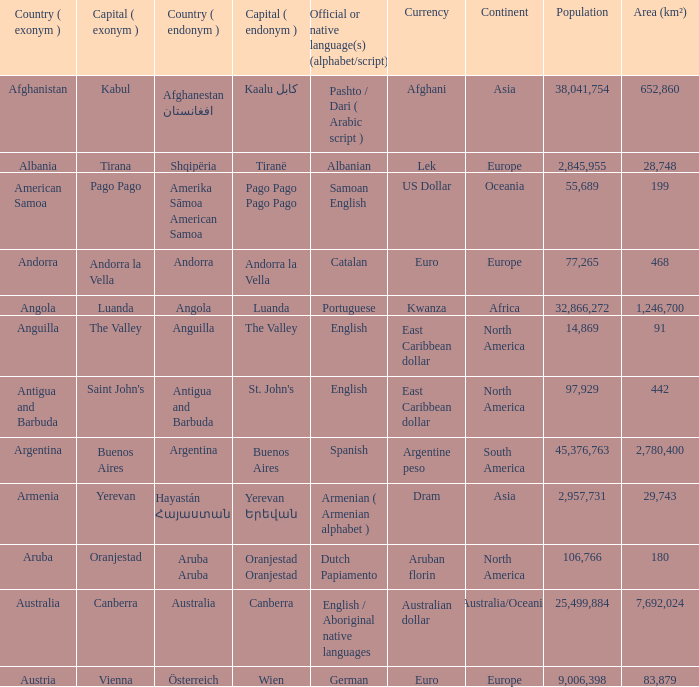Parse the table in full. {'header': ['Country ( exonym )', 'Capital ( exonym )', 'Country ( endonym )', 'Capital ( endonym )', 'Official or native language(s) (alphabet/script)', 'Currency', 'Continent', 'Population', 'Area (km²)'], 'rows': [['Afghanistan', 'Kabul', 'Afghanestan افغانستان', 'Kaalu كابل', 'Pashto / Dari ( Arabic script )', 'Afghani', 'Asia', '38,041,754', '652,860'], ['Albania', 'Tirana', 'Shqipëria', 'Tiranë', 'Albanian', 'Lek', 'Europe', '2,845,955', '28,748'], ['American Samoa', 'Pago Pago', 'Amerika Sāmoa American Samoa', 'Pago Pago Pago Pago', 'Samoan English', 'US Dollar', 'Oceania', '55,689', '199'], ['Andorra', 'Andorra la Vella', 'Andorra', 'Andorra la Vella', 'Catalan', 'Euro', 'Europe', '77,265', '468'], ['Angola', 'Luanda', 'Angola', 'Luanda', 'Portuguese', 'Kwanza', 'Africa', '32,866,272', '1,246,700'], ['Anguilla', 'The Valley', 'Anguilla', 'The Valley', 'English', 'East Caribbean dollar', 'North America', '14,869', '91'], ['Antigua and Barbuda', "Saint John's", 'Antigua and Barbuda', "St. John's", 'English', 'East Caribbean dollar', 'North America', '97,929', '442'], ['Argentina', 'Buenos Aires', 'Argentina', 'Buenos Aires', 'Spanish', 'Argentine peso', 'South America', '45,376,763', '2,780,400'], ['Armenia', 'Yerevan', 'Hayastán Հայաստան', 'Yerevan Երեվան', 'Armenian ( Armenian alphabet )', 'Dram', 'Asia', '2,957,731', '29,743'], ['Aruba', 'Oranjestad', 'Aruba Aruba', 'Oranjestad Oranjestad', 'Dutch Papiamento', 'Aruban florin', 'North America', '106,766', '180'], ['Australia', 'Canberra', 'Australia', 'Canberra', 'English / Aboriginal native languages', 'Australian dollar', 'Australia/Oceania', '25,499,884', '7,692,024'], ['Austria', 'Vienna', 'Österreich', 'Wien', 'German', 'Euro', 'Europe', '9,006,398', '83,879']]} What official or native languages are spoken in the country whose capital city is Canberra? English / Aboriginal native languages. 